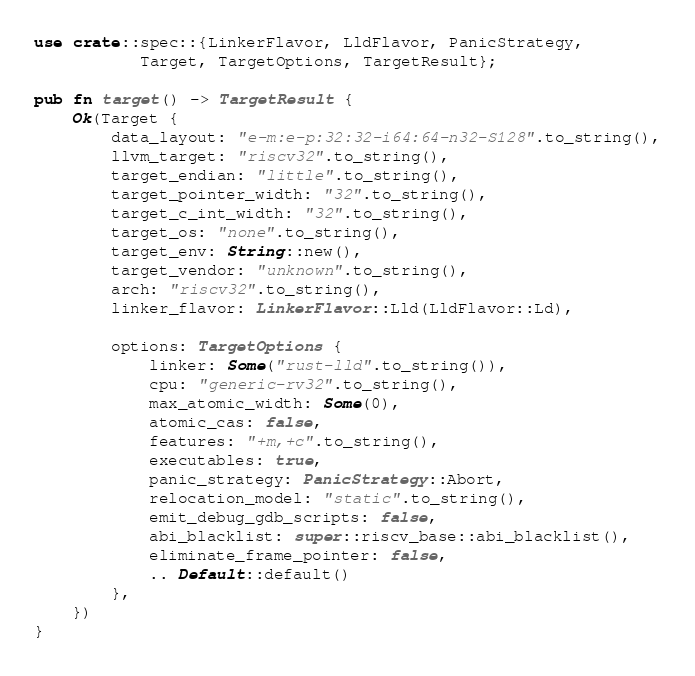Convert code to text. <code><loc_0><loc_0><loc_500><loc_500><_Rust_>use crate::spec::{LinkerFlavor, LldFlavor, PanicStrategy,
           Target, TargetOptions, TargetResult};

pub fn target() -> TargetResult {
    Ok(Target {
        data_layout: "e-m:e-p:32:32-i64:64-n32-S128".to_string(),
        llvm_target: "riscv32".to_string(),
        target_endian: "little".to_string(),
        target_pointer_width: "32".to_string(),
        target_c_int_width: "32".to_string(),
        target_os: "none".to_string(),
        target_env: String::new(),
        target_vendor: "unknown".to_string(),
        arch: "riscv32".to_string(),
        linker_flavor: LinkerFlavor::Lld(LldFlavor::Ld),

        options: TargetOptions {
            linker: Some("rust-lld".to_string()),
            cpu: "generic-rv32".to_string(),
            max_atomic_width: Some(0),
            atomic_cas: false,
            features: "+m,+c".to_string(),
            executables: true,
            panic_strategy: PanicStrategy::Abort,
            relocation_model: "static".to_string(),
            emit_debug_gdb_scripts: false,
            abi_blacklist: super::riscv_base::abi_blacklist(),
            eliminate_frame_pointer: false,
            .. Default::default()
        },
    })
}
</code> 